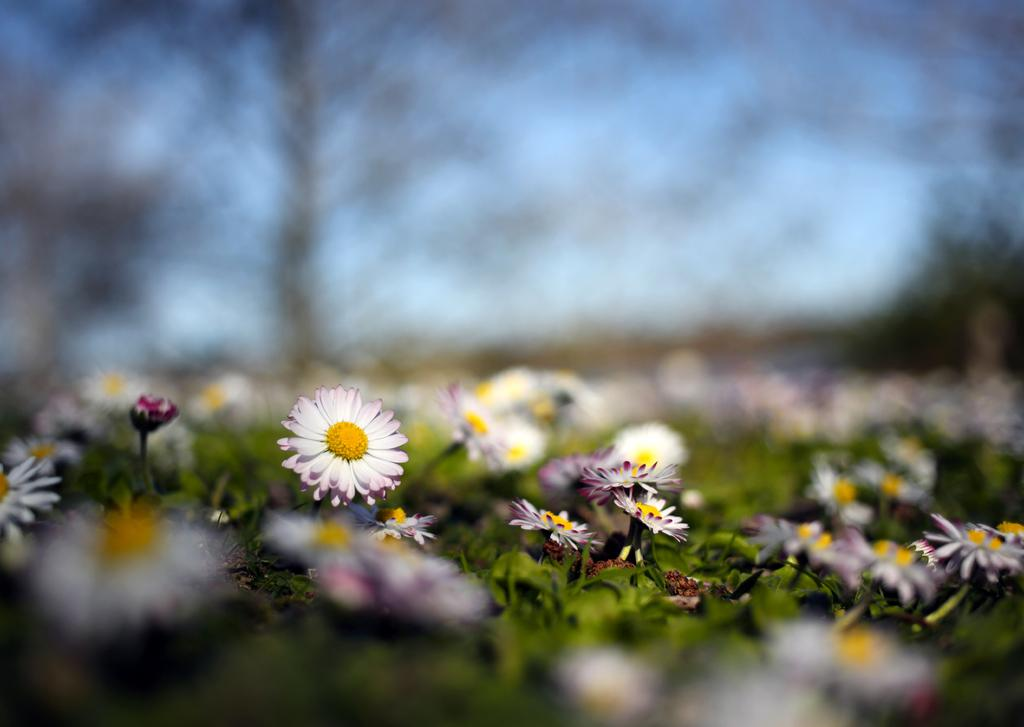What type of plants can be seen in the image? There are plants with flowers in the image. Can you describe the background of the image? The background of the image is blurred. What type of umbrella is being used to protect the plants from the belief in the image? There is no umbrella or belief present in the image; it only features plants with flowers and a blurred background. 